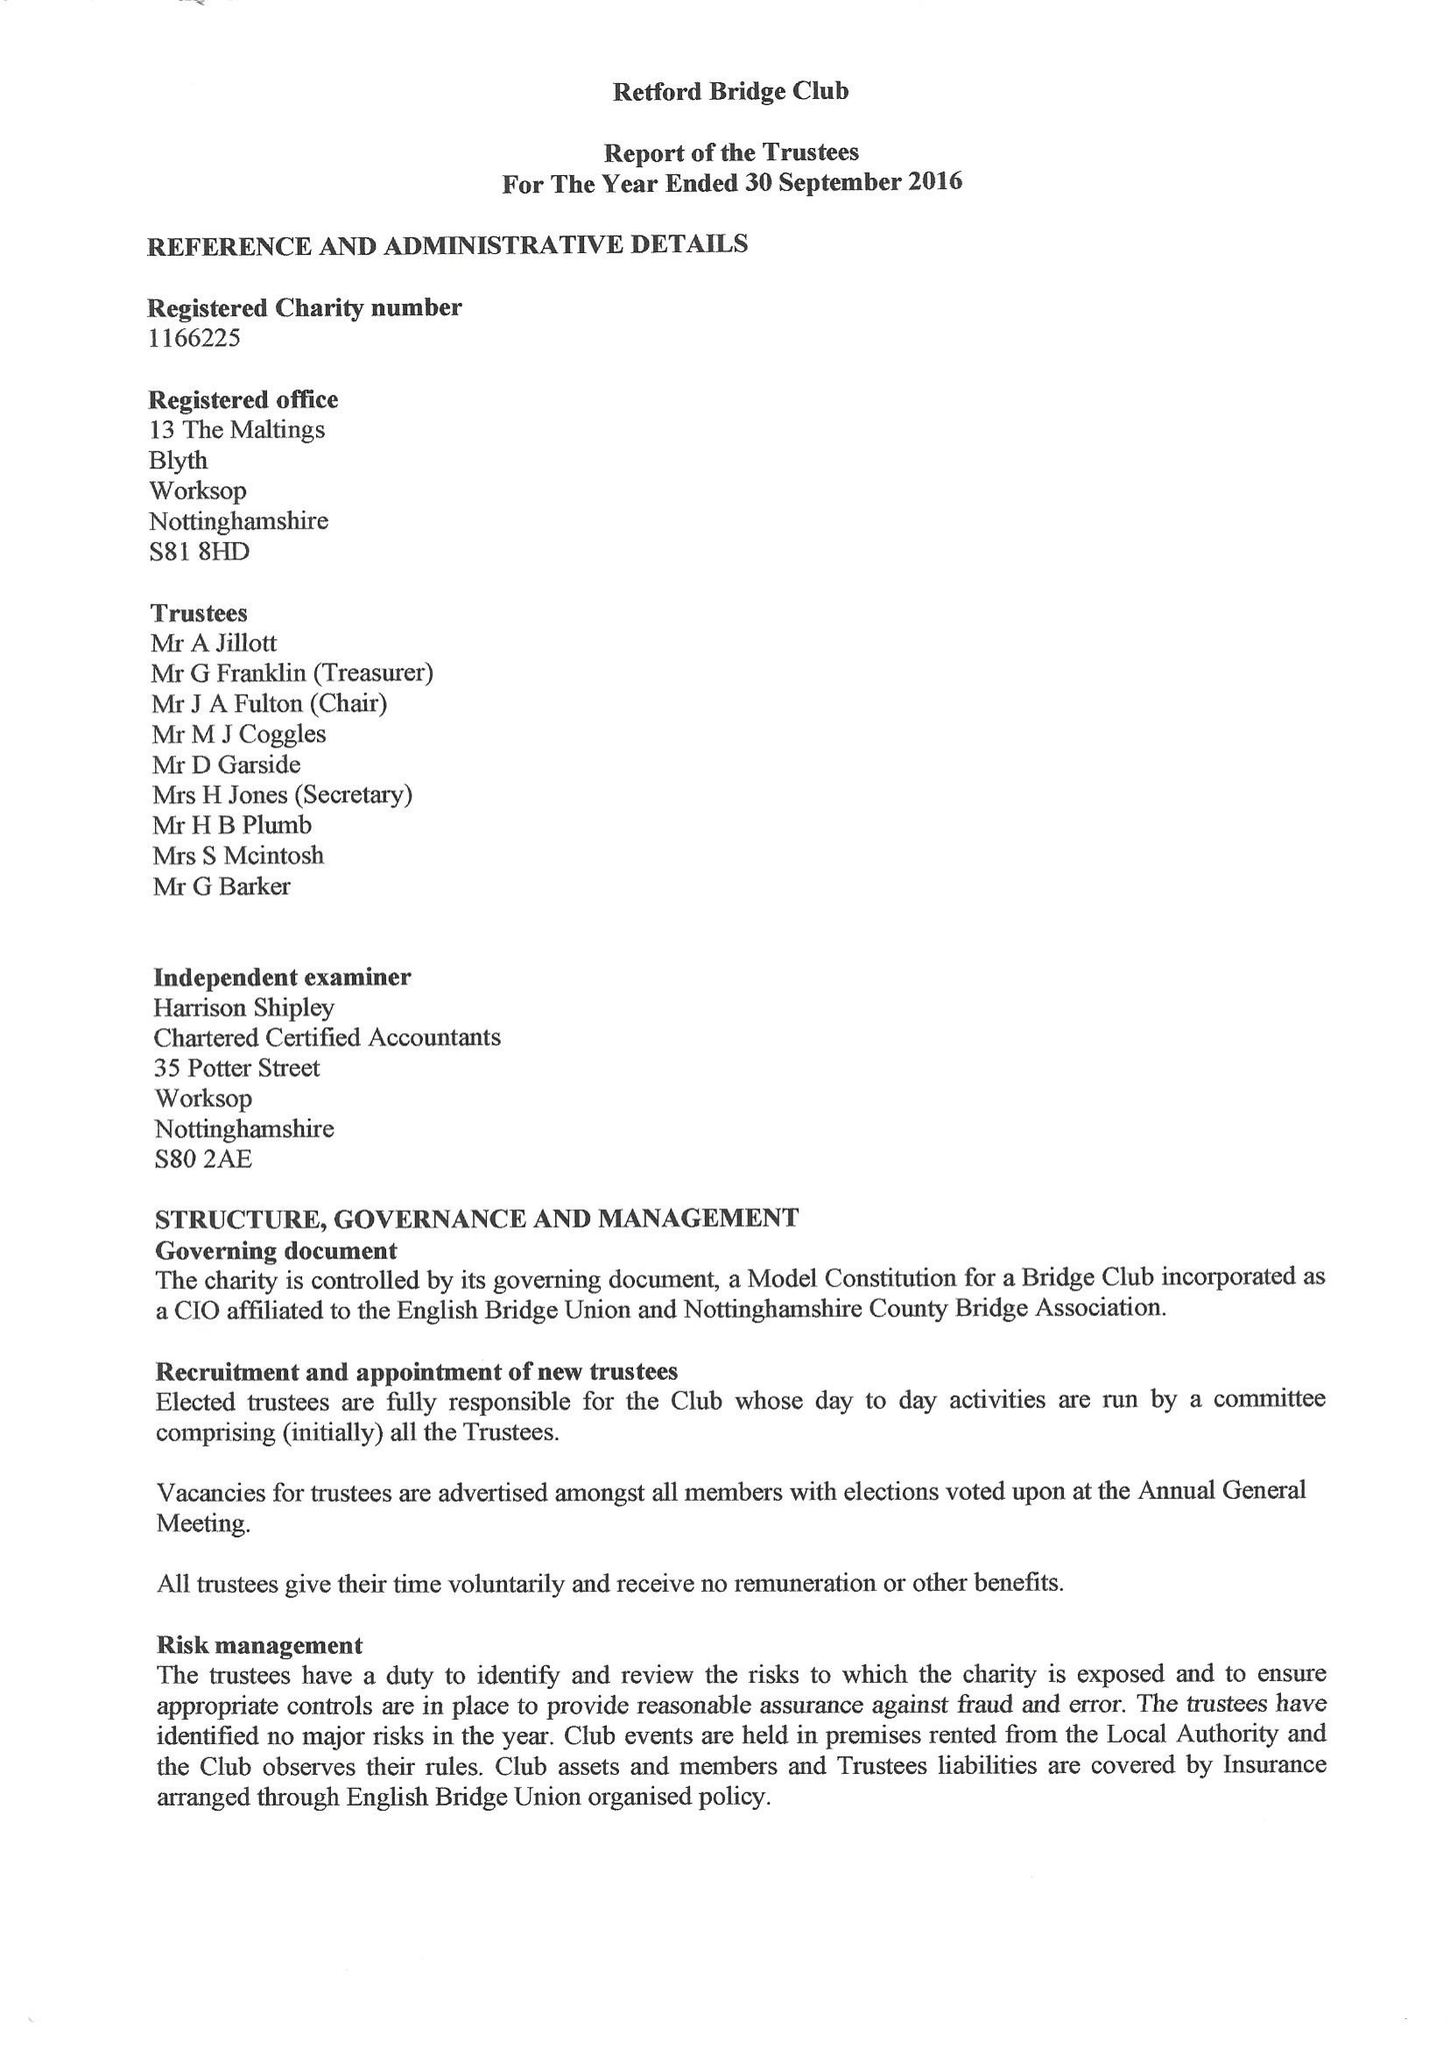What is the value for the report_date?
Answer the question using a single word or phrase. 2016-09-30 